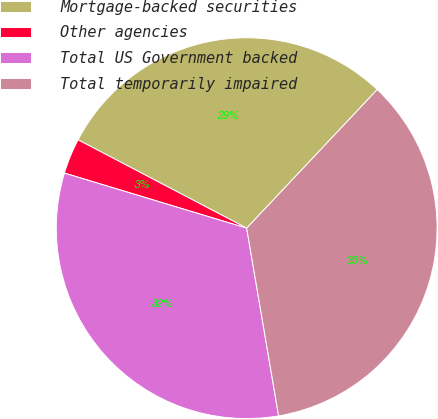<chart> <loc_0><loc_0><loc_500><loc_500><pie_chart><fcel>Mortgage-backed securities<fcel>Other agencies<fcel>Total US Government backed<fcel>Total temporarily impaired<nl><fcel>29.34%<fcel>3.01%<fcel>32.35%<fcel>35.29%<nl></chart> 